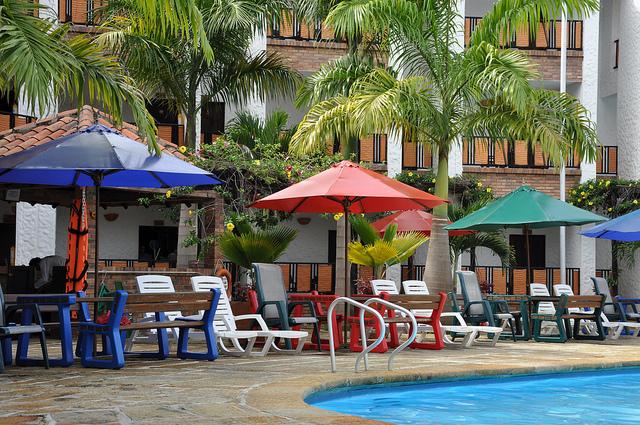What number of red umbrellas are in this scene?
Write a very short answer. 2. What kind of chairs are between the benches?
Be succinct. Lounge. Would people come here to relax?
Concise answer only. Yes. Is this picture largely in focus?
Give a very brief answer. Yes. Does the blue umbrella advertise a product?
Quick response, please. No. 